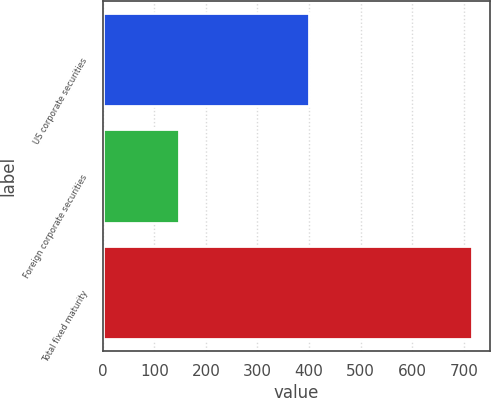<chart> <loc_0><loc_0><loc_500><loc_500><bar_chart><fcel>US corporate securities<fcel>Foreign corporate securities<fcel>Total fixed maturity<nl><fcel>399<fcel>148<fcel>715<nl></chart> 